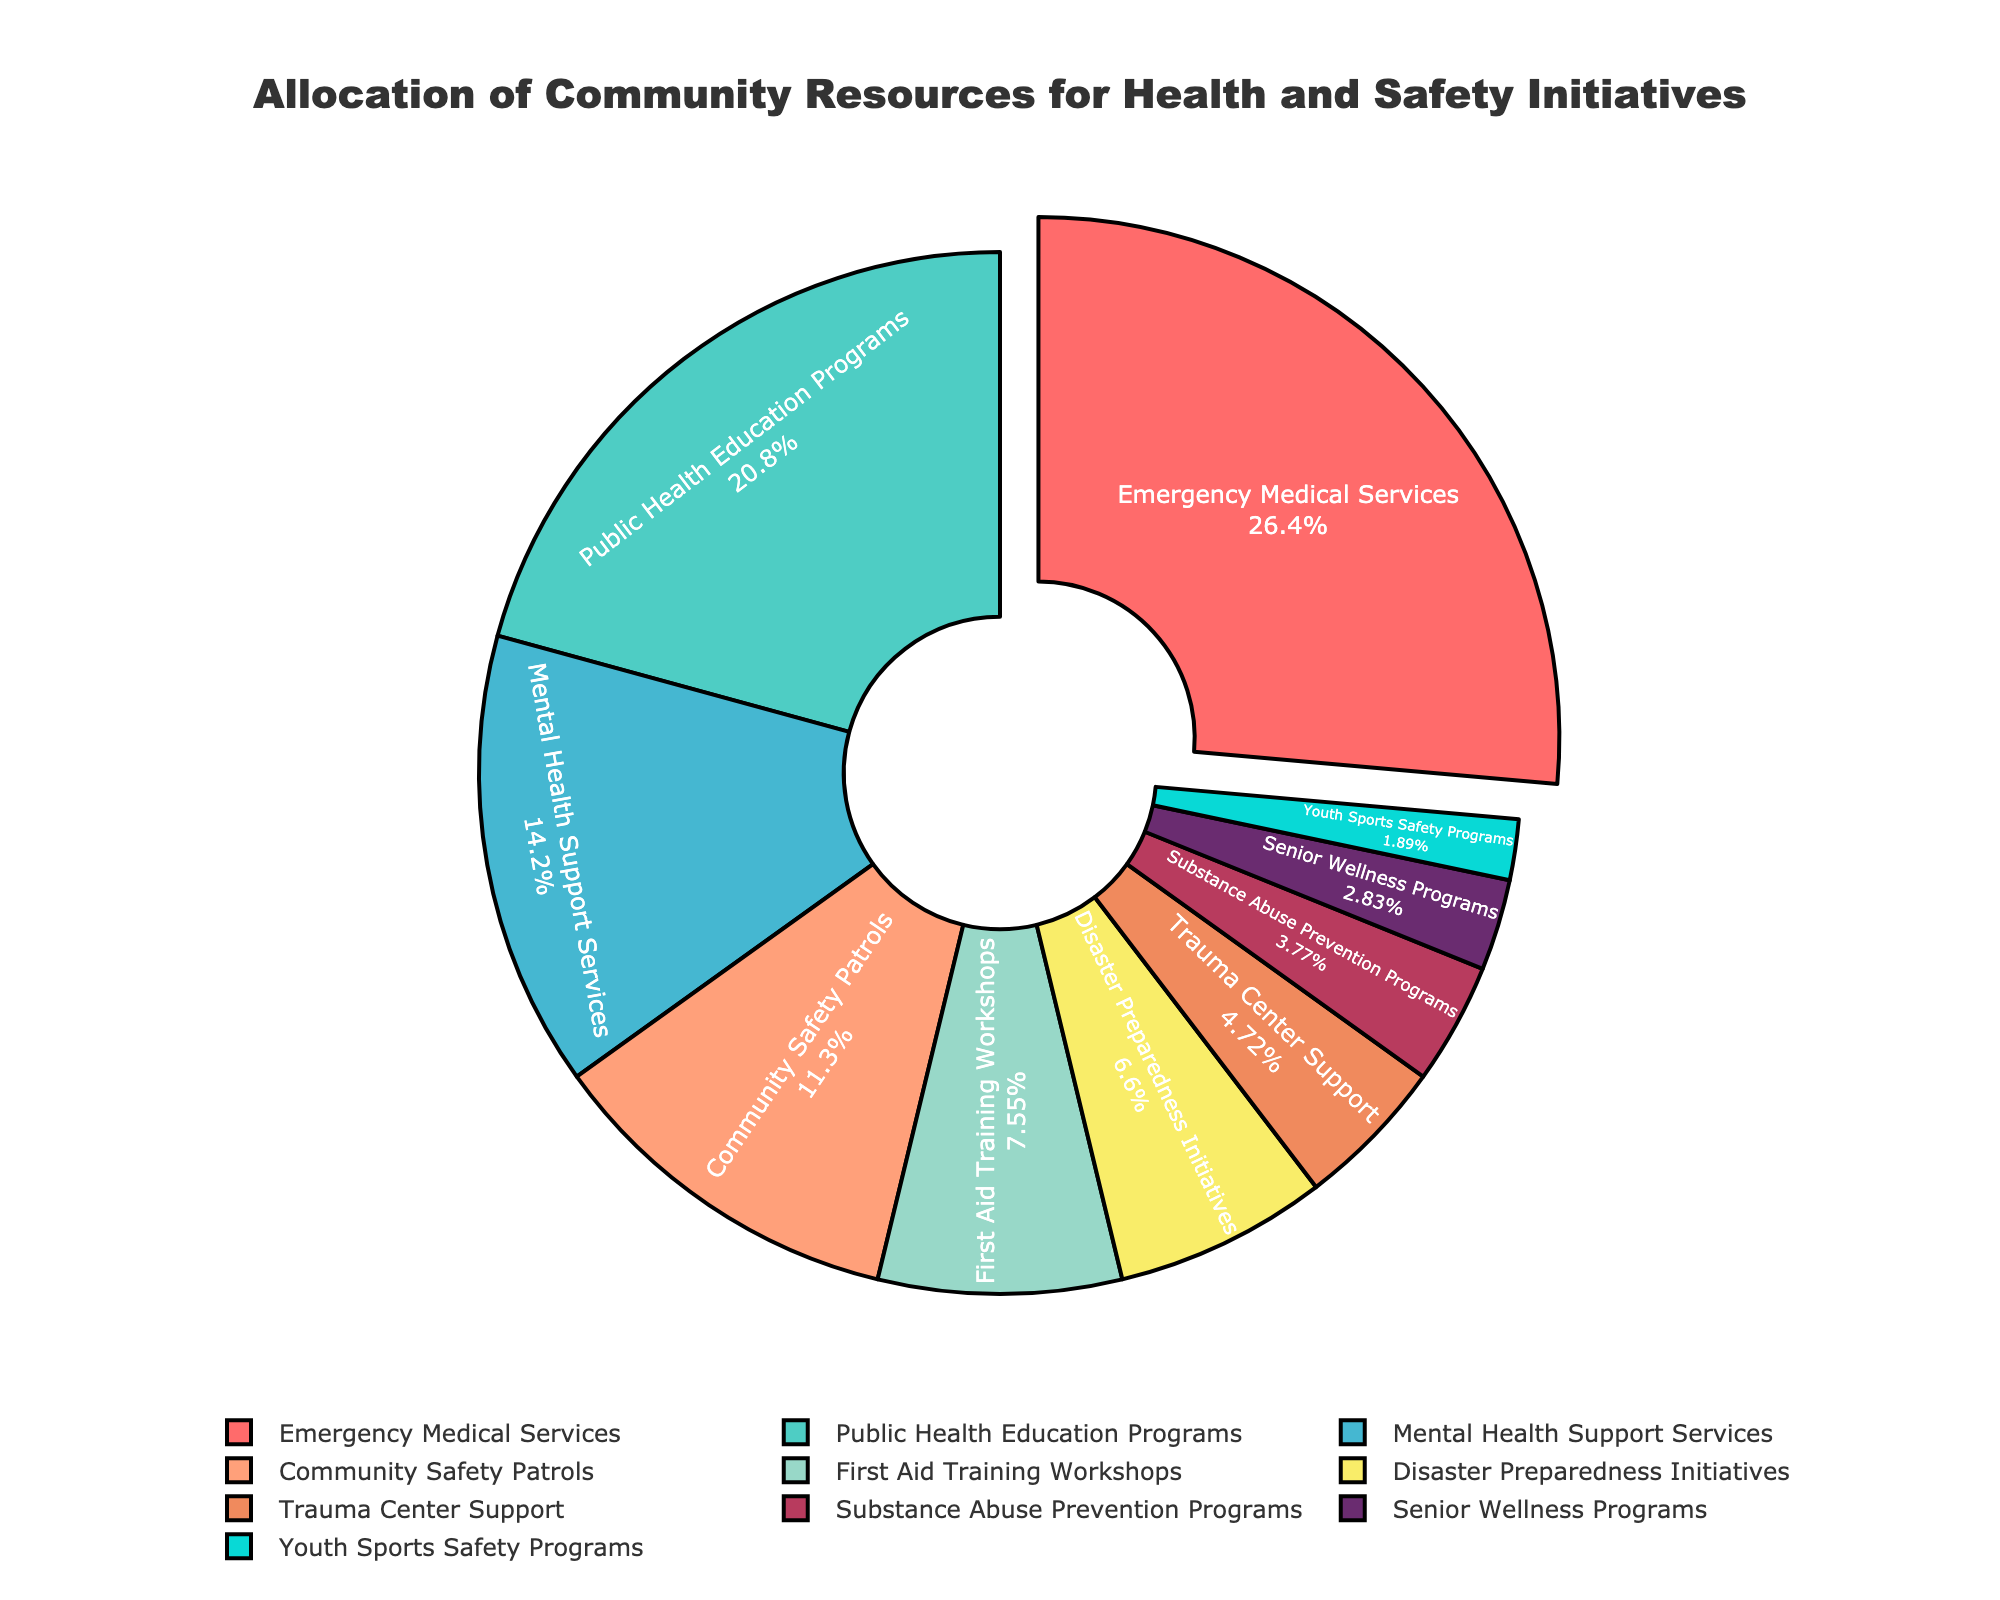What percentage of the community resources is allocated to Emergency Medical Services (EMS)? Check the figure and find the slice labeled "Emergency Medical Services" and note its percentage.
Answer: 28% What is the sum of the percentages for Mental Health Support Services and Substance Abuse Prevention Programs? Locate the slices for Mental Health Support Services and Substance Abuse Prevention Programs in the figure, and add their percentages: 15% + 4%.
Answer: 19% Which category receives a larger allocation, Public Health Education Programs or Community Safety Patrols? Compare the percentages of Public Health Education Programs and Community Safety Patrols by checking their respective slices in the figure.
Answer: Public Health Education Programs What is the difference in percentage allocation between First Aid Training Workshops and Disaster Preparedness Initiatives? Locate the slices for First Aid Training Workshops and Disaster Preparedness Initiatives in the figure and calculate the difference: 8% - 7%.
Answer: 1% Which categories have an allocation of less than 5%? Identify the slices in the figure with percentages less than 5% and list their categories.
Answer: Substance Abuse Prevention Programs, Senior Wellness Programs, Youth Sports Safety Programs What is the combined percentage of resources allocated to Youth Sports Safety Programs and Senior Wellness Programs? Find the slices for Youth Sports Safety Programs and Senior Wellness Programs in the figure, then add their percentages: 2% + 3%.
Answer: 5% How does the percentage for Trauma Center Support compare to that for Community Safety Patrols? Compare the percentages of Trauma Center Support and Community Safety Patrols by looking at their slices in the figure.
Answer: Trauma Center Support is 5%, which is less than Community Safety Patrols at 12% Which category stands out visually in the pie chart and why? Look for the slice that is visually distinct, such as being pulled out from the pie or having a different design element. In this case, the Emergency Medical Services slice is distinct because it is pulled out.
Answer: Emergency Medical Services, because it is pulled out What percentage more is allocated to Public Health Education Programs compared to First Aid Training Workshops? Subtract the percentage for First Aid Training Workshops from the percentage for Public Health Education Programs: 22% - 8%.
Answer: 14% If Community Safety Patrols and Mental Health Support Services were combined into one category, what would be their total percentage allocation? Add the percentages for Community Safety Patrols and Mental Health Support Services: 12% + 15%.
Answer: 27% 